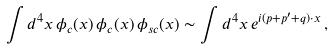<formula> <loc_0><loc_0><loc_500><loc_500>\int d ^ { 4 } x \, \phi _ { c } ( x ) \, \phi _ { c } ( x ) \, \phi _ { s c } ( x ) \sim \int d ^ { 4 } x \, e ^ { i ( p + p ^ { \prime } + q ) \cdot x } \, ,</formula> 